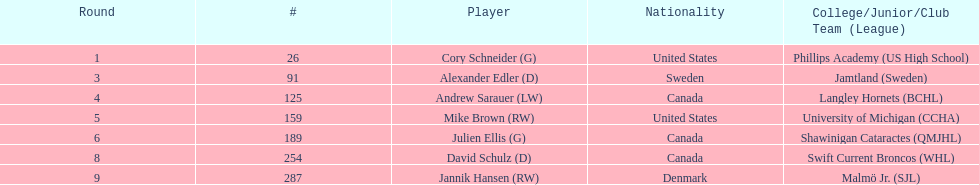List only the american players. Cory Schneider (G), Mike Brown (RW). 